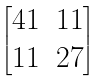<formula> <loc_0><loc_0><loc_500><loc_500>\begin{bmatrix} 4 1 & 1 1 \\ 1 1 & 2 7 \end{bmatrix}</formula> 